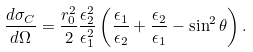<formula> <loc_0><loc_0><loc_500><loc_500>\frac { d \sigma _ { C } } { d \Omega } = \frac { r _ { 0 } ^ { 2 } } { 2 } \frac { \epsilon _ { 2 } ^ { 2 } } { \epsilon _ { 1 } ^ { 2 } } \left ( \frac { \epsilon _ { 1 } } { \epsilon _ { 2 } } + \frac { \epsilon _ { 2 } } { \epsilon _ { 1 } } - \sin ^ { 2 } \theta \right ) .</formula> 